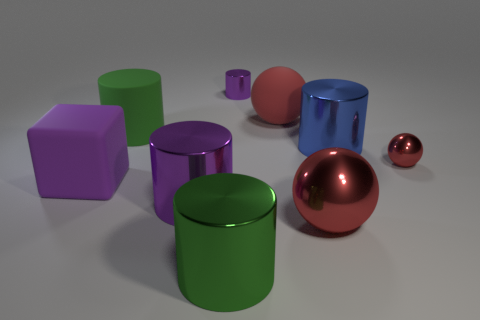Subtract all green shiny cylinders. How many cylinders are left? 4 Subtract all green cylinders. How many cylinders are left? 3 Subtract 3 spheres. How many spheres are left? 0 Add 3 blue shiny cylinders. How many blue shiny cylinders are left? 4 Add 7 small metal cylinders. How many small metal cylinders exist? 8 Subtract 0 blue blocks. How many objects are left? 9 Subtract all blocks. How many objects are left? 8 Subtract all green balls. Subtract all purple cylinders. How many balls are left? 3 Subtract all red blocks. How many purple cylinders are left? 2 Subtract all big green metallic cylinders. Subtract all big rubber balls. How many objects are left? 7 